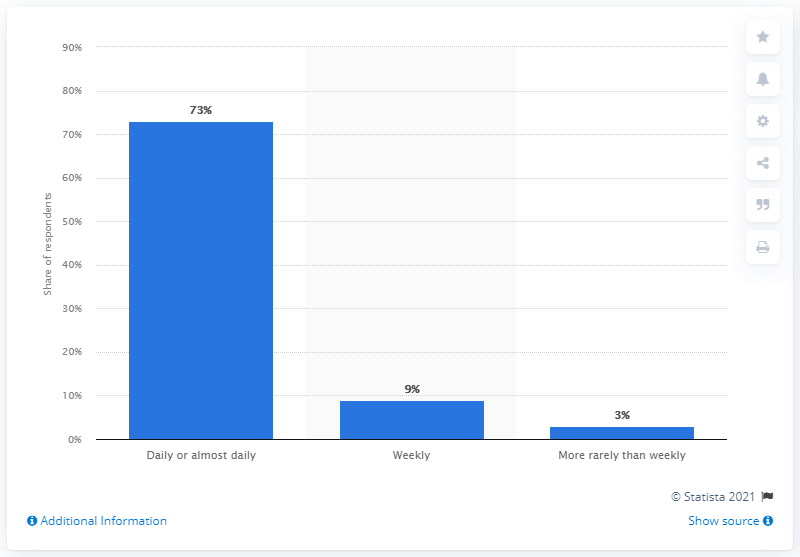Highlight a few significant elements in this photo. The value of daily or almost daily users is 73... The difference between weekly and less frequent users or respondents was identified in the findings, with weekly users being more likely to respond than those who used the service less frequently. 